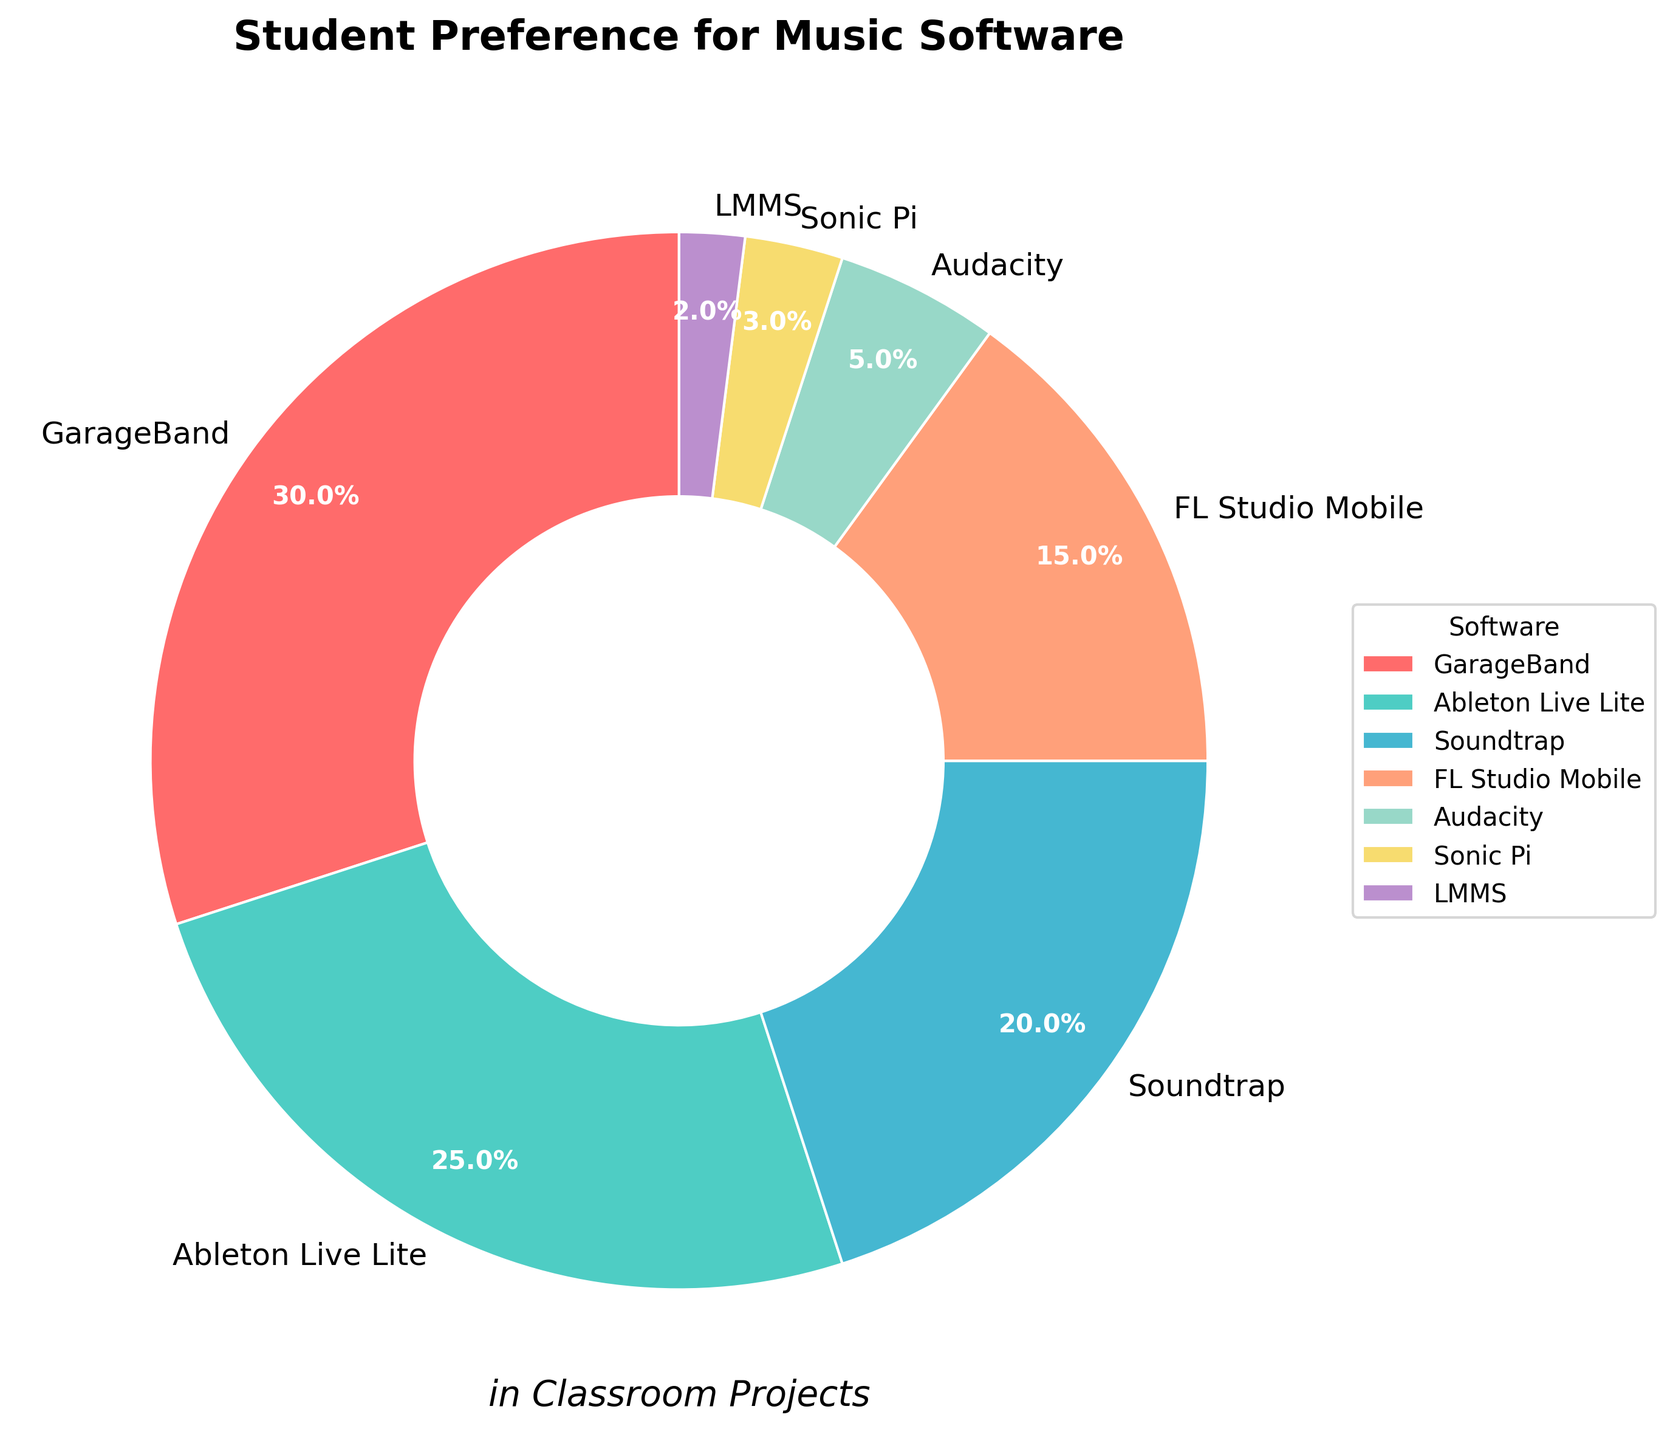Which music software is most preferred by students? From the pie chart, the section labeled "GarageBand" is the largest, indicating that it has the highest percentage.
Answer: GarageBand Which two music software combined have a preference percentage of 40%? From the pie chart, Soundtrap (20%) and FL Studio Mobile (15%) add up to 35%. Instead, Ableton Live Lite (25%) and Soundtrap (20%) add up to 45%. The closest combination is Ableton Live Lite and Soundtrap which add up to 45%.
Answer: Ableton Live Lite and Soundtrap What is the difference in preference percentage between the most and least preferred software? The most preferred software is GarageBand with 30%, and the least preferred is LMMS with 2%. The difference is 30% - 2% = 28%.
Answer: 28% Which software has nearly half the preference percentage of Ableton Live Lite? Ableton Live Lite has a preference of 25%. Nearly half of that is 12.5%. Among the options, FL Studio Mobile has a 15% preference, which is close to half.
Answer: FL Studio Mobile What color represents Soundtrap in the pie chart? Referring to the color sections in the chart, Soundtrap is represented by the blue section.
Answer: Blue Which software preferences add up to more than 50%? Summing the preferences: GarageBand (30%) + Ableton Live Lite (25%) already equals 55%, which is more than 50%.
Answer: GarageBand and Ableton Live Lite How much greater is the preference for GarageBand compared to Audacity? The preference for GarageBand is 30%, and Audacity is 5%. The difference is 30% - 5% = 25%.
Answer: 25% If Sonic Pi and LMMS combined were to double their preference percentage, what would be the new total? Currently, Sonic Pi is at 3% and LMMS at 2%, totaling 3% + 2% = 5%. Doubling this combined percentage results in 5% x 2 = 10%.
Answer: 10% What is the percentage difference between the second most preferred (Ableton Live Lite) and the third most preferred (Soundtrap) software? Ableton Live Lite has a preference of 25% and Soundtrap has 20%. The difference is 25% - 20% = 5%.
Answer: 5% If FL Studio Mobile were to gain the same preference percentage as Soundtrap, what would be the combined preference percentage of both? Both would have a preference of 20%. The combined preference would be 20% + 20% = 40%.
Answer: 40% 